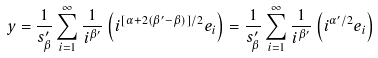<formula> <loc_0><loc_0><loc_500><loc_500>y = \frac { 1 } { s _ { \beta } ^ { \prime } } \sum _ { i = 1 } ^ { \infty } \frac { 1 } { i ^ { \beta ^ { \prime } } } \left ( i ^ { [ \alpha + 2 ( \beta ^ { \prime } - \beta ) ] / 2 } e _ { i } \right ) = \frac { 1 } { s _ { \beta } ^ { \prime } } \sum _ { i = 1 } ^ { \infty } \frac { 1 } { i ^ { \beta ^ { \prime } } } \left ( i ^ { \alpha ^ { \prime } / 2 } e _ { i } \right )</formula> 